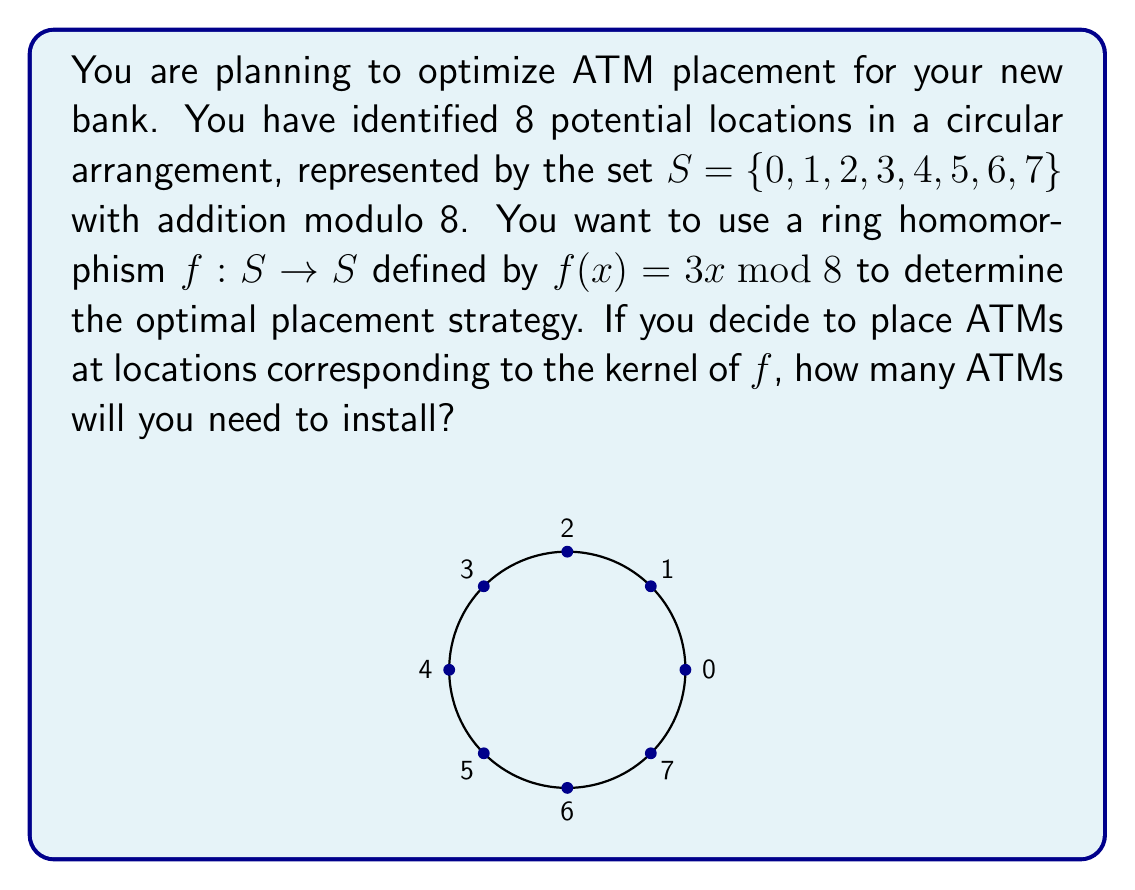Provide a solution to this math problem. Let's approach this step-by-step:

1) First, we need to understand what a ring homomorphism is. A ring homomorphism is a function between two rings that preserves the ring operations (addition and multiplication).

2) In this case, we have a function $f: S \rightarrow S$ defined by $f(x) = 3x \bmod 8$.

3) The kernel of a ring homomorphism is the set of elements that map to the identity element (in this case, 0). Mathematically, $\ker(f) = \{x \in S : f(x) = 0\}$.

4) To find the kernel, we need to solve the equation:
   $3x \equiv 0 \pmod{8}$

5) This is equivalent to finding values of $x$ where 8 divides $3x$.

6) Let's check each element of $S$:
   $f(0) = 3 \cdot 0 \bmod 8 = 0$
   $f(1) = 3 \cdot 1 \bmod 8 = 3$
   $f(2) = 3 \cdot 2 \bmod 8 = 6$
   $f(3) = 3 \cdot 3 \bmod 8 = 1$
   $f(4) = 3 \cdot 4 \bmod 8 = 4$
   $f(5) = 3 \cdot 5 \bmod 8 = 7$
   $f(6) = 3 \cdot 6 \bmod 8 = 2$
   $f(7) = 3 \cdot 7 \bmod 8 = 5$

7) From this, we can see that $f(x) = 0$ only when $x = 0$ or $x = 4$.

8) Therefore, the kernel of $f$ is $\ker(f) = \{0, 4\}$.

9) The number of elements in the kernel is 2.

Thus, if you decide to place ATMs at locations corresponding to the kernel of $f$, you will need to install 2 ATMs.
Answer: 2 ATMs 